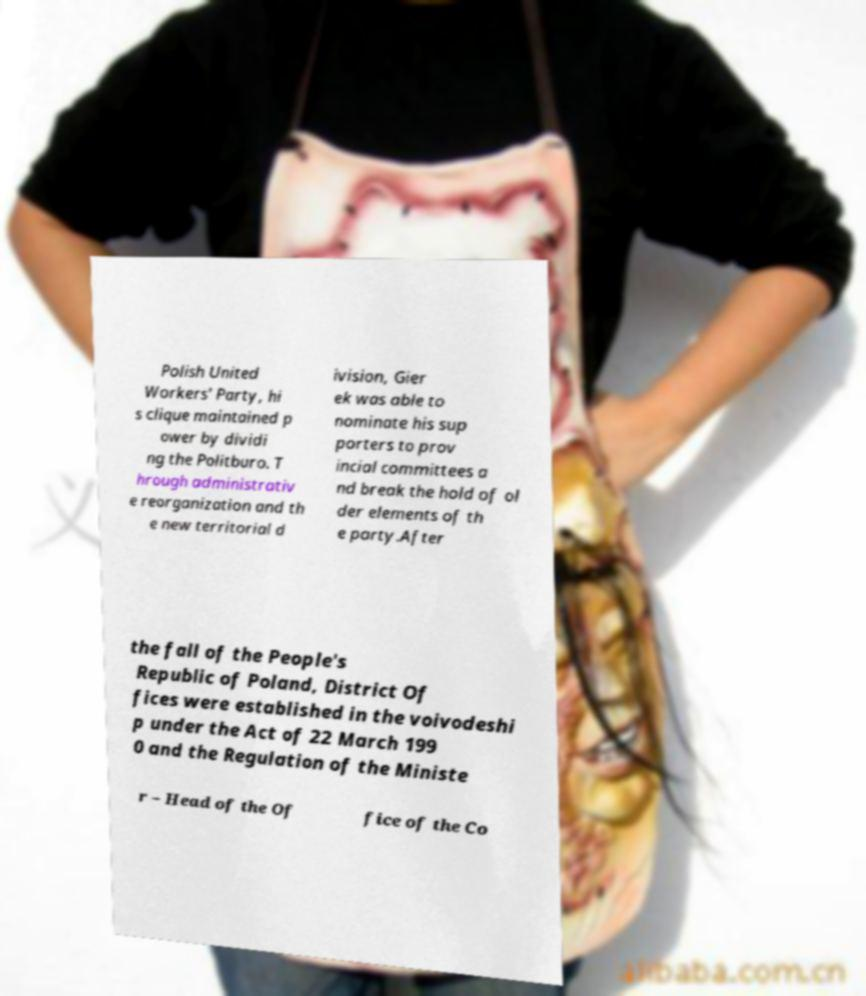For documentation purposes, I need the text within this image transcribed. Could you provide that? Polish United Workers' Party, hi s clique maintained p ower by dividi ng the Politburo. T hrough administrativ e reorganization and th e new territorial d ivision, Gier ek was able to nominate his sup porters to prov incial committees a nd break the hold of ol der elements of th e party.After the fall of the People's Republic of Poland, District Of fices were established in the voivodeshi p under the Act of 22 March 199 0 and the Regulation of the Ministe r – Head of the Of fice of the Co 